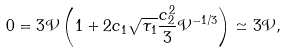Convert formula to latex. <formula><loc_0><loc_0><loc_500><loc_500>0 = 3 \mathcal { V } \left ( 1 + 2 c _ { 1 } \sqrt { \tau _ { 1 } } \frac { c _ { 2 } ^ { 2 } } { 3 } \mathcal { V } ^ { - 1 / 3 } \right ) \simeq 3 \mathcal { V } ,</formula> 